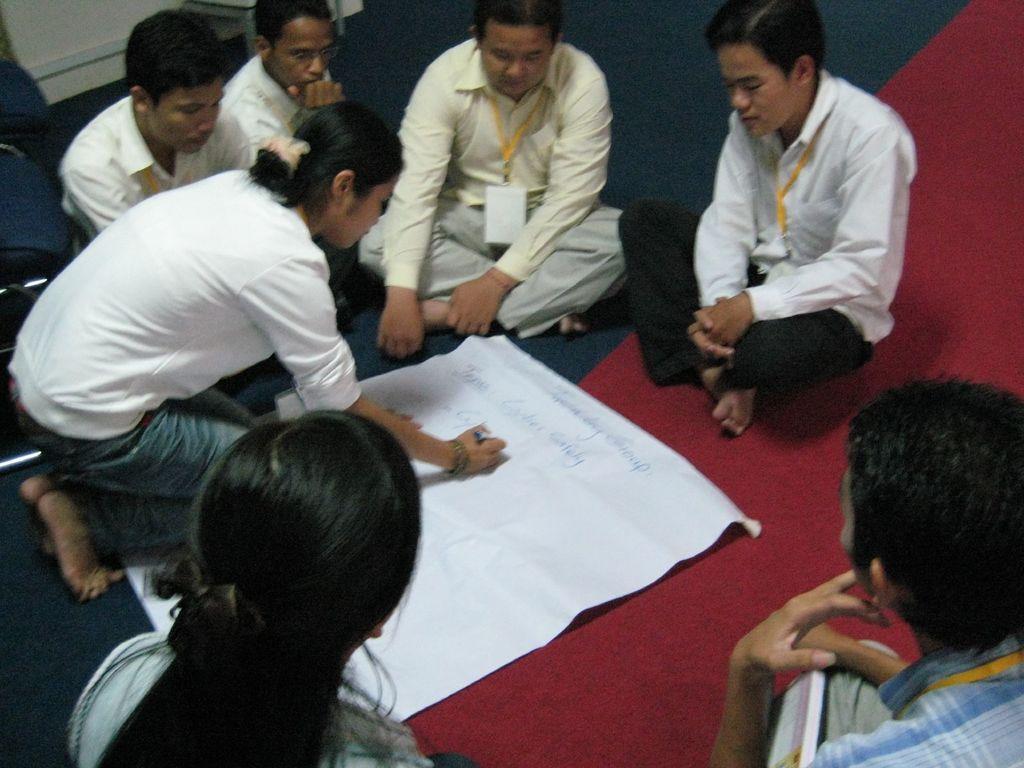How would you summarize this image in a sentence or two? In this image I can see the group of people with different color dresses. These people are sitting on the red and navy blue color mat. I can see one person is holding the pen and there is a paper on the mat. 